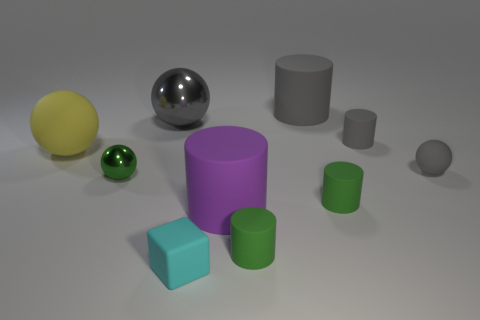Subtract 1 balls. How many balls are left? 3 Subtract all purple cylinders. How many cylinders are left? 4 Subtract all big purple cylinders. How many cylinders are left? 4 Subtract all purple balls. Subtract all red cylinders. How many balls are left? 4 Subtract all cubes. How many objects are left? 9 Subtract 1 green spheres. How many objects are left? 9 Subtract all small brown metal objects. Subtract all small cubes. How many objects are left? 9 Add 3 big gray metal spheres. How many big gray metal spheres are left? 4 Add 9 small metal objects. How many small metal objects exist? 10 